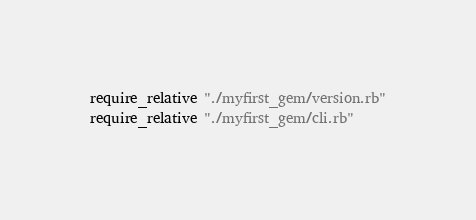Convert code to text. <code><loc_0><loc_0><loc_500><loc_500><_Ruby_>require_relative "./myfirst_gem/version.rb"
require_relative "./myfirst_gem/cli.rb"

</code> 